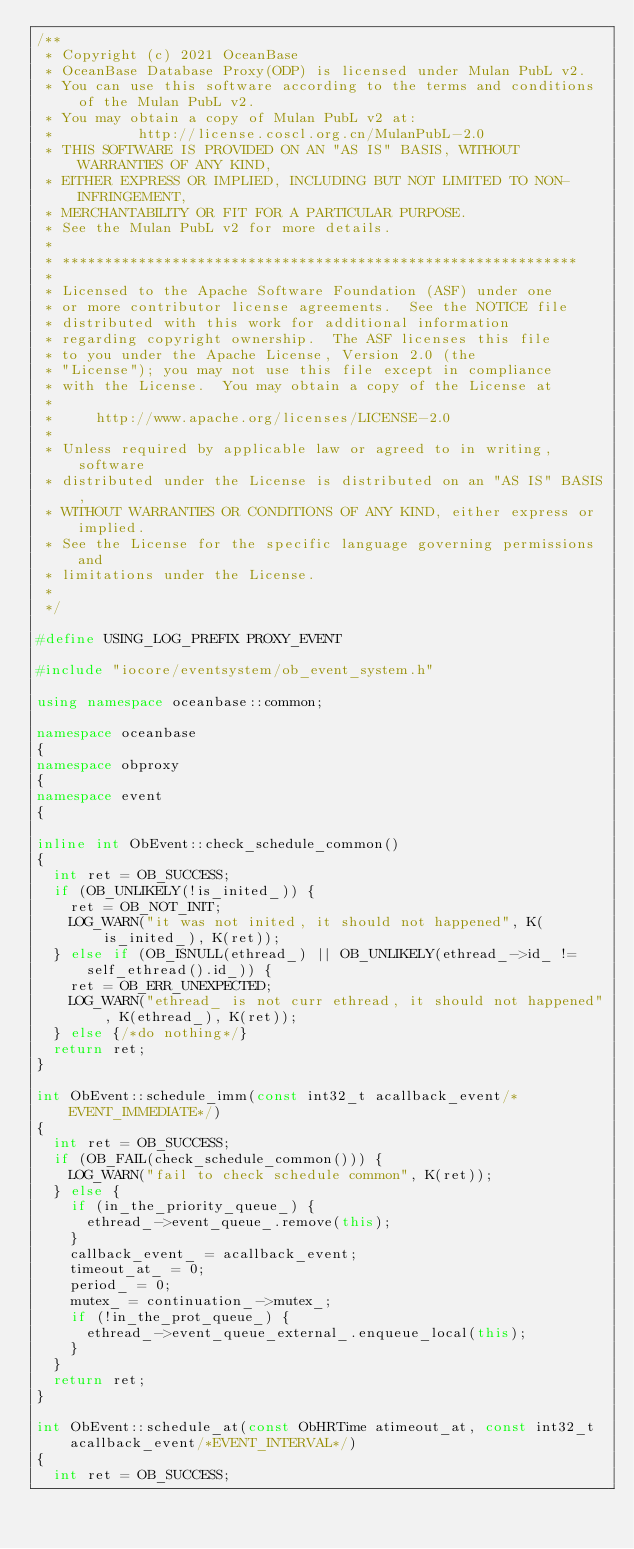<code> <loc_0><loc_0><loc_500><loc_500><_C++_>/**
 * Copyright (c) 2021 OceanBase
 * OceanBase Database Proxy(ODP) is licensed under Mulan PubL v2.
 * You can use this software according to the terms and conditions of the Mulan PubL v2.
 * You may obtain a copy of Mulan PubL v2 at:
 *          http://license.coscl.org.cn/MulanPubL-2.0
 * THIS SOFTWARE IS PROVIDED ON AN "AS IS" BASIS, WITHOUT WARRANTIES OF ANY KIND,
 * EITHER EXPRESS OR IMPLIED, INCLUDING BUT NOT LIMITED TO NON-INFRINGEMENT,
 * MERCHANTABILITY OR FIT FOR A PARTICULAR PURPOSE.
 * See the Mulan PubL v2 for more details.
 *
 * *************************************************************
 *
 * Licensed to the Apache Software Foundation (ASF) under one
 * or more contributor license agreements.  See the NOTICE file
 * distributed with this work for additional information
 * regarding copyright ownership.  The ASF licenses this file
 * to you under the Apache License, Version 2.0 (the
 * "License"); you may not use this file except in compliance
 * with the License.  You may obtain a copy of the License at
 *
 *     http://www.apache.org/licenses/LICENSE-2.0
 *
 * Unless required by applicable law or agreed to in writing, software
 * distributed under the License is distributed on an "AS IS" BASIS,
 * WITHOUT WARRANTIES OR CONDITIONS OF ANY KIND, either express or implied.
 * See the License for the specific language governing permissions and
 * limitations under the License.
 *
 */

#define USING_LOG_PREFIX PROXY_EVENT

#include "iocore/eventsystem/ob_event_system.h"

using namespace oceanbase::common;

namespace oceanbase
{
namespace obproxy
{
namespace event
{

inline int ObEvent::check_schedule_common()
{
  int ret = OB_SUCCESS;
  if (OB_UNLIKELY(!is_inited_)) {
    ret = OB_NOT_INIT;
    LOG_WARN("it was not inited, it should not happened", K(is_inited_), K(ret));
  } else if (OB_ISNULL(ethread_) || OB_UNLIKELY(ethread_->id_ != self_ethread().id_)) {
    ret = OB_ERR_UNEXPECTED;
    LOG_WARN("ethread_ is not curr ethread, it should not happened", K(ethread_), K(ret));
  } else {/*do nothing*/}
  return ret;
}

int ObEvent::schedule_imm(const int32_t acallback_event/*EVENT_IMMEDIATE*/)
{
  int ret = OB_SUCCESS;
  if (OB_FAIL(check_schedule_common())) {
    LOG_WARN("fail to check schedule common", K(ret));
  } else {
    if (in_the_priority_queue_) {
      ethread_->event_queue_.remove(this);
    }
    callback_event_ = acallback_event;
    timeout_at_ = 0;
    period_ = 0;
    mutex_ = continuation_->mutex_;
    if (!in_the_prot_queue_) {
      ethread_->event_queue_external_.enqueue_local(this);
    }
  }
  return ret;
}

int ObEvent::schedule_at(const ObHRTime atimeout_at, const int32_t acallback_event/*EVENT_INTERVAL*/)
{
  int ret = OB_SUCCESS;</code> 